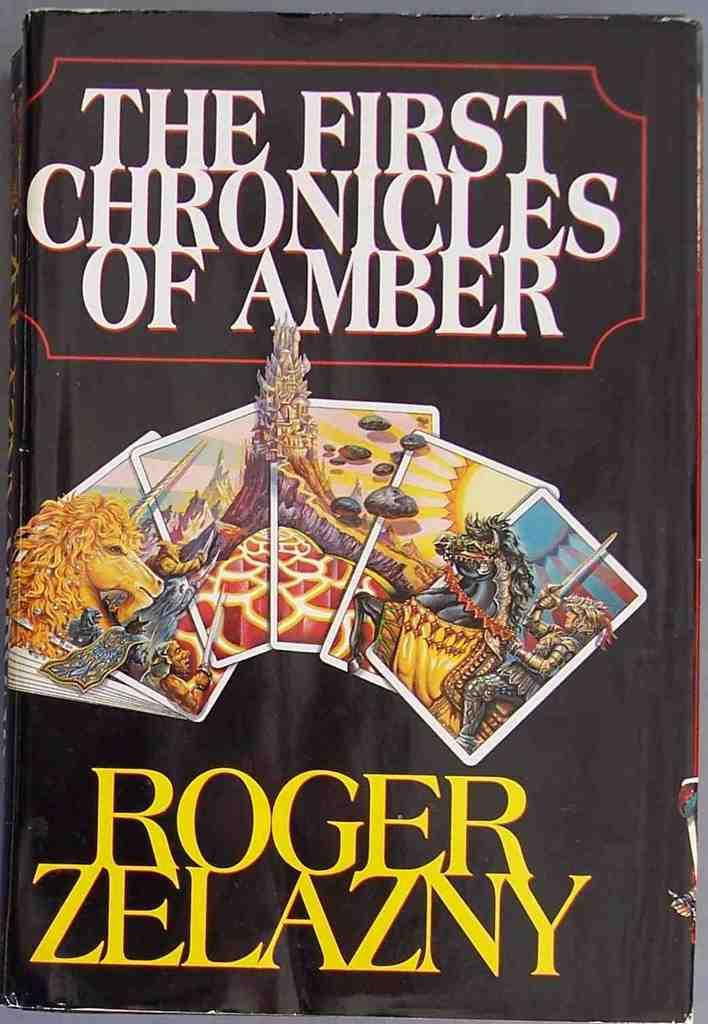<image>
Share a concise interpretation of the image provided. A black paperback book called The First Chronicles of Amber. 